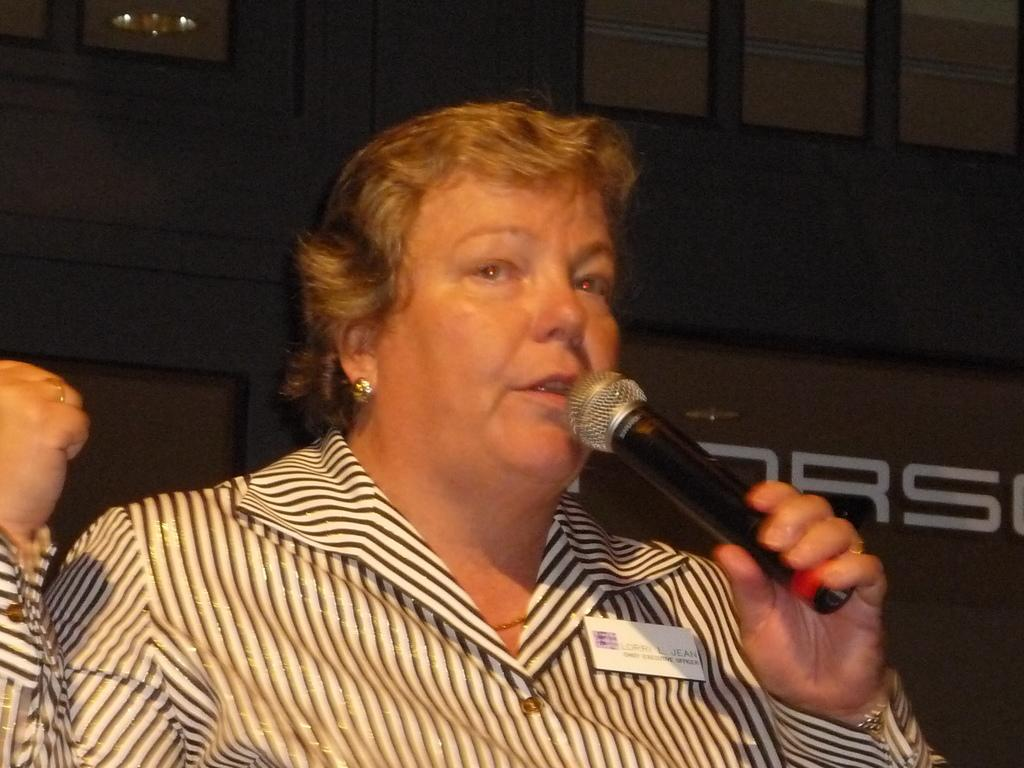Who is the main subject in the image? There is a woman in the image. What is the woman holding in the image? The woman is holding a microphone. What is the woman doing in the image? The woman is talking. Can you describe any additional details about the woman's appearance? There is a badge on her shirt. What can be seen in the background of the image? There is text visible in the background of the image. What type of animal is sitting next to the woman in the image? There is no animal present in the image. How many passengers are visible in the image? The image only features the woman, so there is only one passenger visible. 